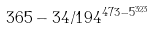<formula> <loc_0><loc_0><loc_500><loc_500>3 6 5 - 3 4 / 1 9 4 ^ { 4 7 3 - 5 ^ { 3 2 3 } }</formula> 